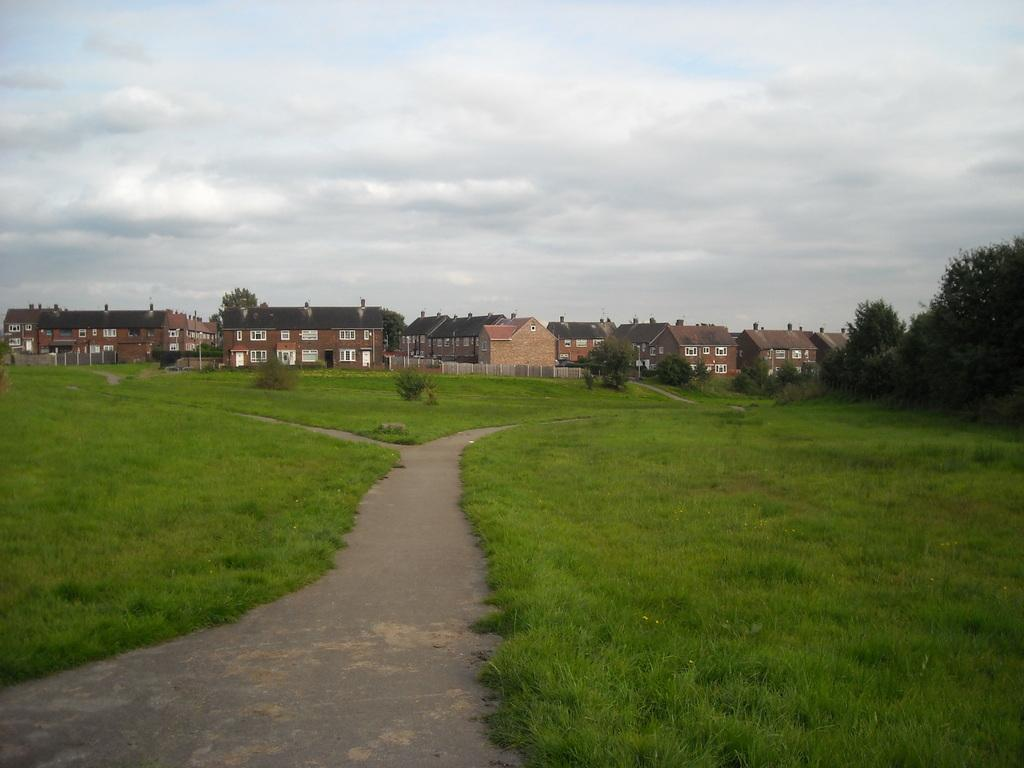What type of terrain is visible at the bottom of the image? There is grass and a walkway at the bottom of the image. What structures can be seen in the background of the image? There are houses in the background of the image. What type of vegetation is present in the background of the image? There are trees in the background of the image. What is visible at the top of the image? The sky is visible at the top of the image. What type of creature is bleeding in the image? There is no creature present in the image, nor is there any blood visible. 